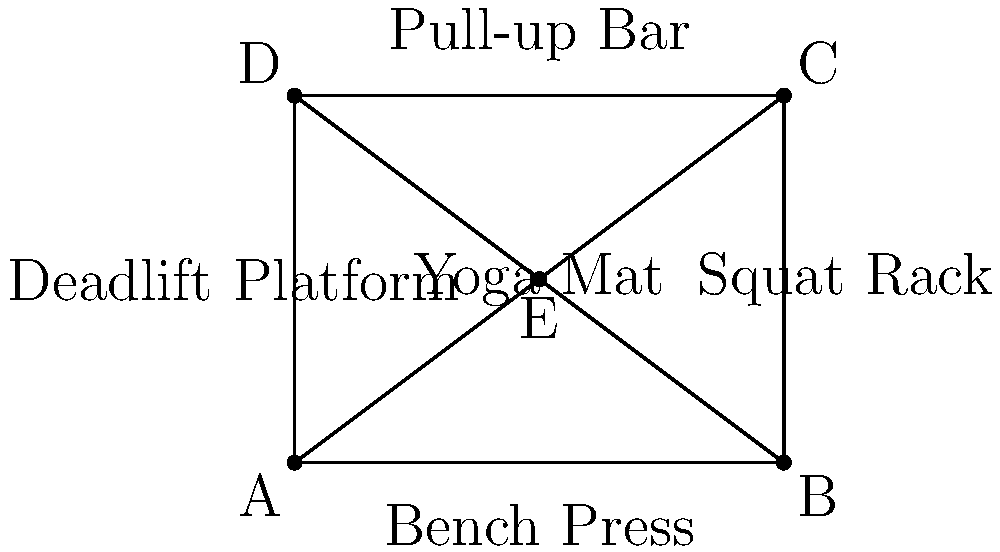In your gym's circuit training area, exercise stations are set up at points A, B, C, and D, forming a rectangle. A yoga mat is placed at point E in the center. You want to complete a circuit that includes all stations and the yoga mat. What is the shortest possible path that visits all points exactly once and returns to the starting point? Express your answer in terms of the rectangle's width (w) and height (h). To find the shortest path, we need to consider all possible routes and compare their lengths. Let's break this down step-by-step:

1) First, note that the rectangle has a width of w and a height of h.

2) The diagonal of the rectangle is $\sqrt{w^2 + h^2}$.

3) The distance from any corner to the center (E) is $\frac{1}{2}\sqrt{w^2 + h^2}$.

4) There are several possible paths, but we can narrow it down to two main options:
   a) Corner-to-corner path: A-B-C-D-E-A (or its reverse)
   b) Corner-to-center-to-corner path: A-E-C-B-E-D-A (or variations)

5) Let's calculate the length of path (a):
   $L_a = w + h + w + h + \frac{1}{2}\sqrt{w^2 + h^2} = 2w + 2h + \frac{1}{2}\sqrt{w^2 + h^2}$

6) Now, let's calculate the length of path (b):
   $L_b = \frac{1}{2}\sqrt{w^2 + h^2} + \frac{1}{2}\sqrt{w^2 + h^2} + w + \frac{1}{2}\sqrt{w^2 + h^2} + \frac{1}{2}\sqrt{w^2 + h^2} + h$
   $= 2\sqrt{w^2 + h^2} + w + h$

7) Comparing $L_a$ and $L_b$:
   $L_a = 2w + 2h + \frac{1}{2}\sqrt{w^2 + h^2}$
   $L_b = 2\sqrt{w^2 + h^2} + w + h$

8) $L_b$ is always shorter than $L_a$ for positive w and h.

Therefore, the shortest path is A-E-C-B-E-D-A (or its reverse), with a total length of $2\sqrt{w^2 + h^2} + w + h$.
Answer: $2\sqrt{w^2 + h^2} + w + h$ 